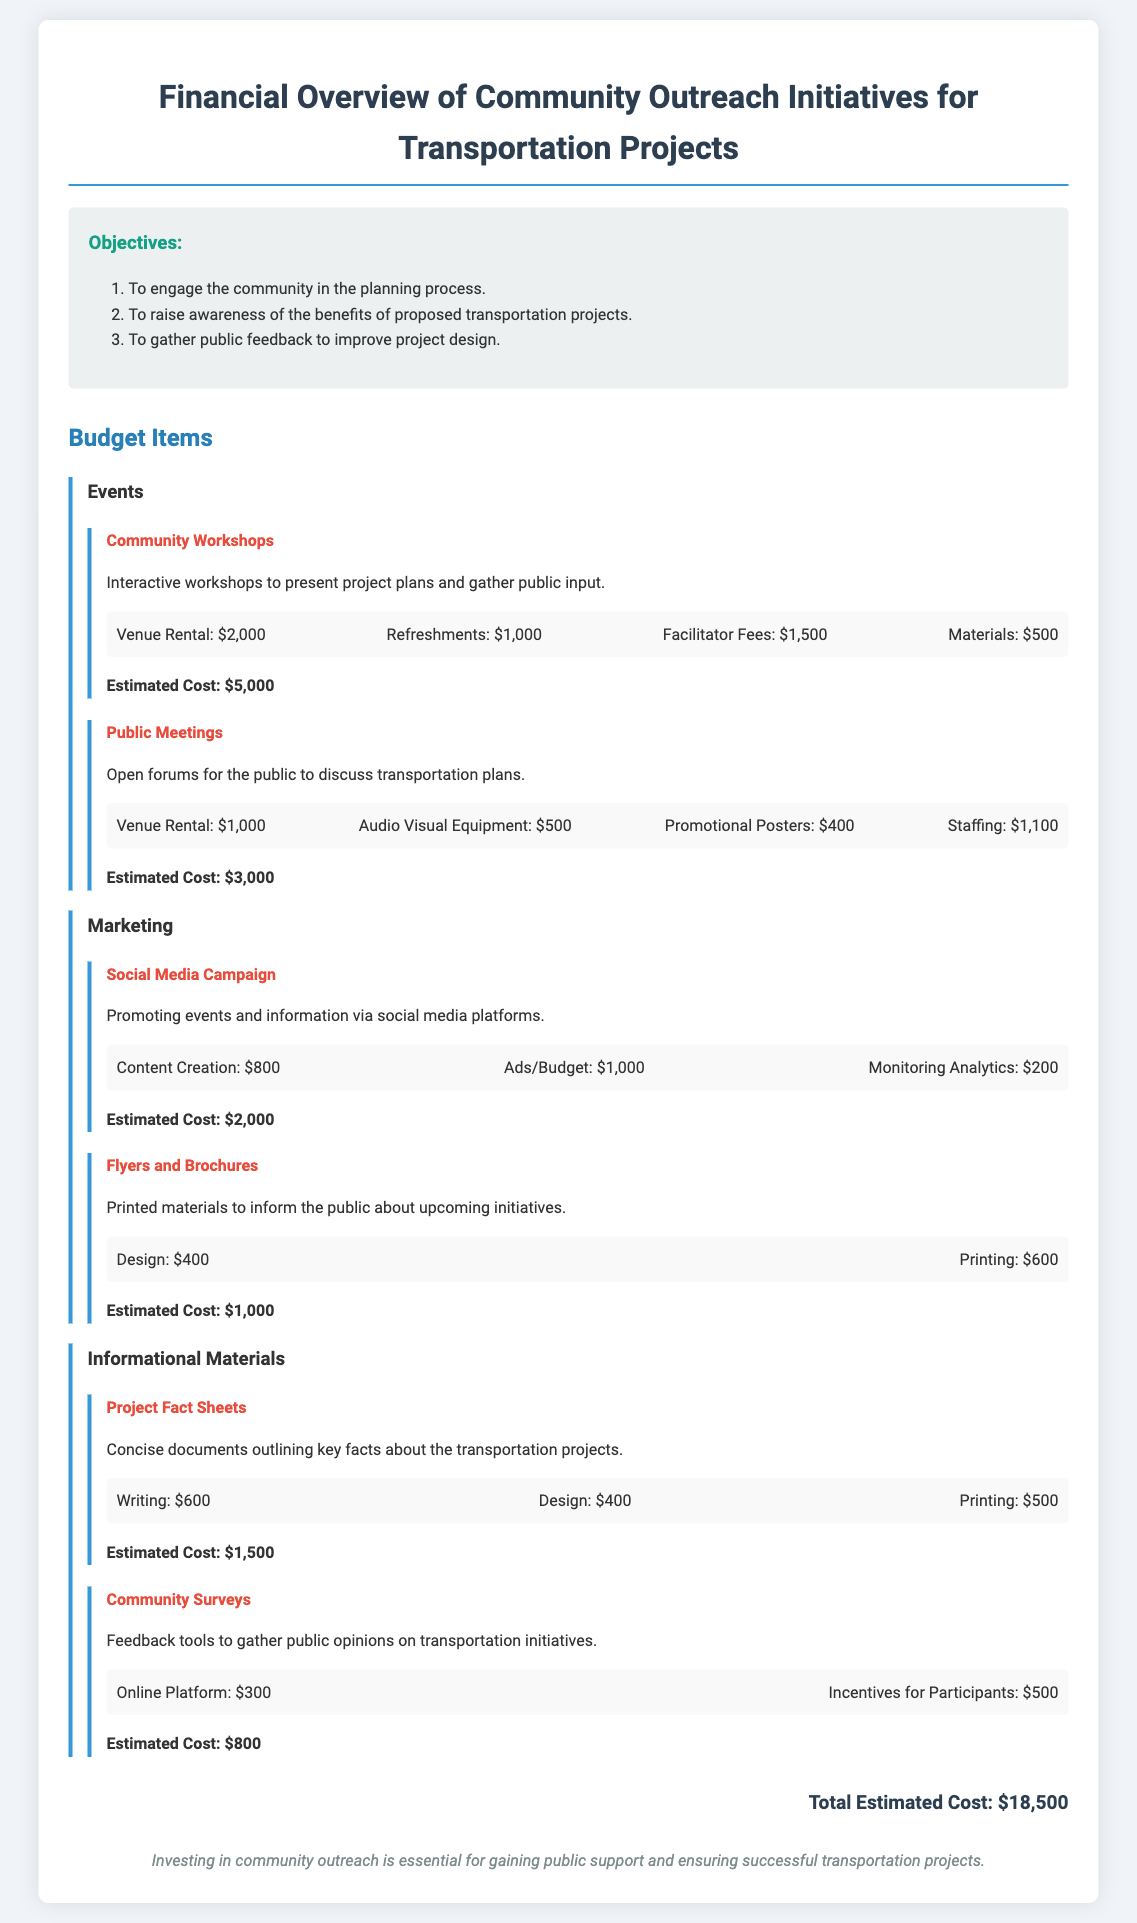What is the total estimated cost? The total estimated cost is provided at the end of the document, which sums up all budget items.
Answer: $18,500 How much does venue rental for community workshops cost? The cost for venue rental is listed under the community workshops budget item.
Answer: $2,000 What is included in the social media campaign budget? The social media campaign budget includes specific costs related to activities as detailed in the budget section.
Answer: Content creation, Ads/Budget, Monitoring Analytics What is the cost for incentives for participants in community surveys? The cost for incentives is specifically mentioned under the community surveys budget item.
Answer: $500 How many objectives are listed in the document? The number of objectives is indicated in the objectives section of the document.
Answer: 3 What is the estimated cost of the public meetings? The estimated cost is provided under the public meetings budget item.
Answer: $3,000 What type of materials are mentioned for the marketing budget? The types of materials are indicated specifically under the marketing section of the budget.
Answer: Flyers and Brochures What is the purpose of community workshops as stated in the document? The purpose is described in the details provided for community workshops in the budget.
Answer: To present project plans and gather public input What aspect of community outreach is emphasized in the conclusion? The conclusion summarizes the importance noted throughout the document.
Answer: Gaining public support 